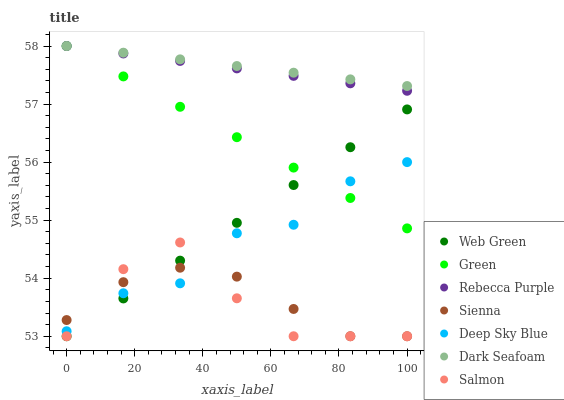Does Salmon have the minimum area under the curve?
Answer yes or no. Yes. Does Dark Seafoam have the maximum area under the curve?
Answer yes or no. Yes. Does Web Green have the minimum area under the curve?
Answer yes or no. No. Does Web Green have the maximum area under the curve?
Answer yes or no. No. Is Green the smoothest?
Answer yes or no. Yes. Is Salmon the roughest?
Answer yes or no. Yes. Is Web Green the smoothest?
Answer yes or no. No. Is Web Green the roughest?
Answer yes or no. No. Does Salmon have the lowest value?
Answer yes or no. Yes. Does Dark Seafoam have the lowest value?
Answer yes or no. No. Does Rebecca Purple have the highest value?
Answer yes or no. Yes. Does Web Green have the highest value?
Answer yes or no. No. Is Web Green less than Dark Seafoam?
Answer yes or no. Yes. Is Rebecca Purple greater than Web Green?
Answer yes or no. Yes. Does Web Green intersect Sienna?
Answer yes or no. Yes. Is Web Green less than Sienna?
Answer yes or no. No. Is Web Green greater than Sienna?
Answer yes or no. No. Does Web Green intersect Dark Seafoam?
Answer yes or no. No. 